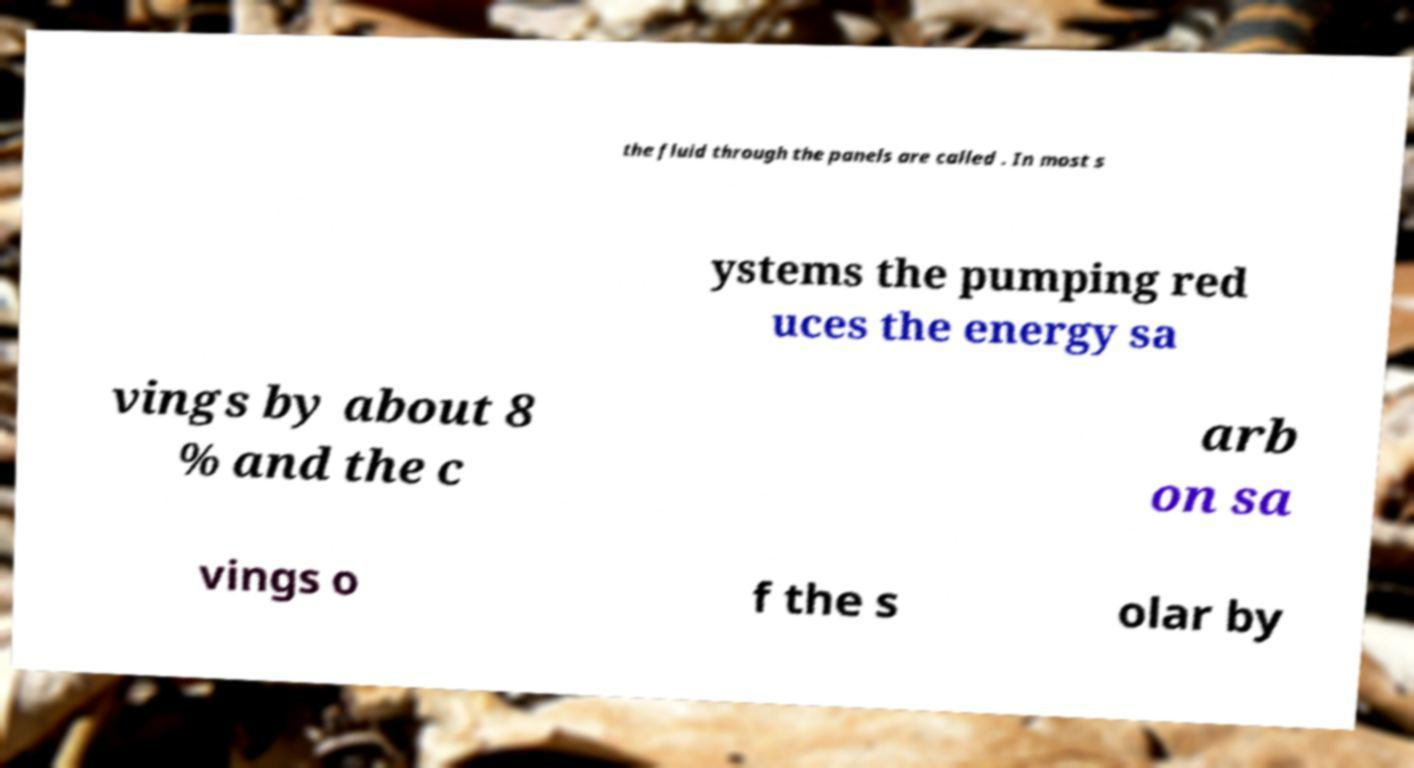For documentation purposes, I need the text within this image transcribed. Could you provide that? the fluid through the panels are called . In most s ystems the pumping red uces the energy sa vings by about 8 % and the c arb on sa vings o f the s olar by 